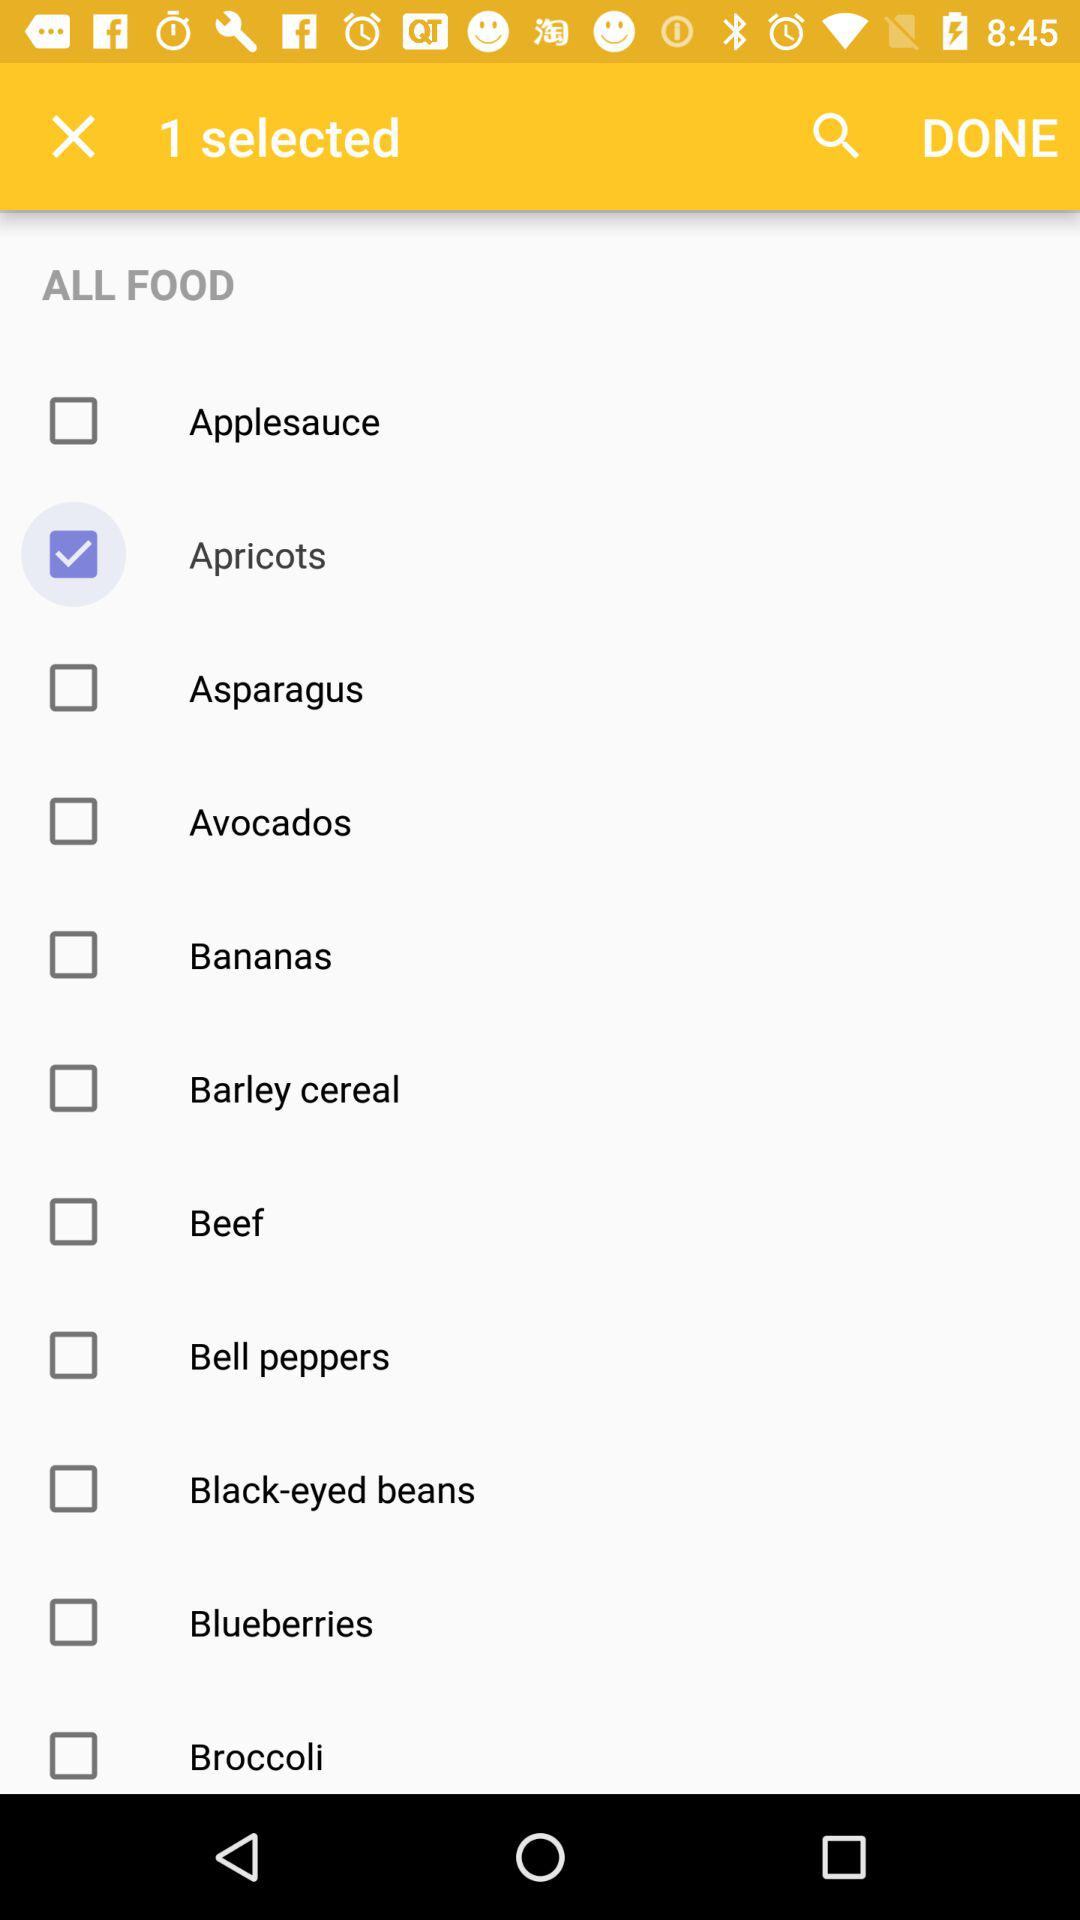How many items have been selected?
Answer the question using a single word or phrase. 1 